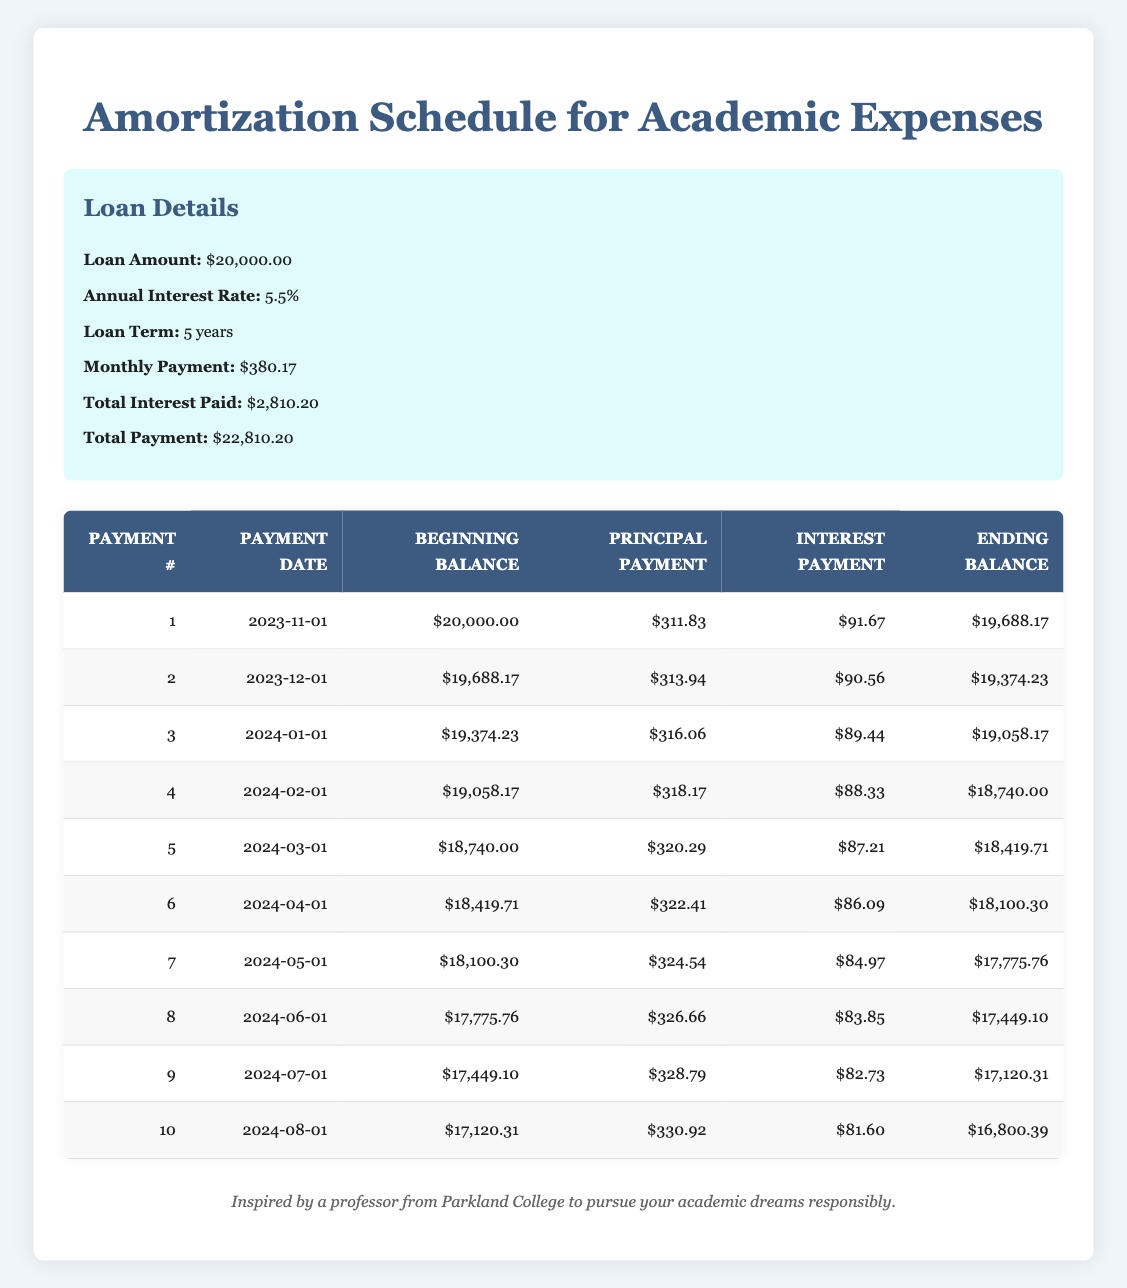What is the initial loan amount? The initial loan amount is stated directly in the loan details section of the table. It's specified as $20,000.00.
Answer: $20,000.00 What was the total interest paid over the life of the loan? Referring to the loan details, the total interest paid is presented clearly as $2,810.20.
Answer: $2,810.20 What is the principal payment of the first payment? The principal payment for the first payment is given explicitly in the first row of the amortization schedule under the "Principal Payment" column, which is $311.83.
Answer: $311.83 Is the interest payment in the second month higher than in the first month? To answer this, compare the "Interest Payment" values in rows one and two of the amortization schedule. The interest payment in the second month is $90.56, while the first month is $91.67. Since $90.56 is less than $91.67, the answer is no.
Answer: No What is the average principal payment over the first 5 payments? First, we sum the principal payments from the first five rows: (311.83 + 313.94 + 316.06 + 318.17 + 320.29) = 1,580.29. There are 5 payments, so we divide this sum by 5 to find the average: 1,580.29 / 5 = 316.06.
Answer: 316.06 How much is the ending balance after the fifth payment? According to the amortization schedule, the ending balance after the fifth payment is stated directly in the row for payment number 5 under the "Ending Balance" column, which is $18,419.71.
Answer: $18,419.71 What is the difference in principal payments between the first payment and the last payment shown? First, identify the principal payment for the last payment shown (10th payment), which is $330.92. The first payment's principal is $311.83. The difference is calculated as $330.92 - $311.83 = $19.09.
Answer: $19.09 Are there any payments where the principal payment exceeds $325.00? Reviewing the "Principal Payment" column, we see that the principal payments for payment numbers 7, 8, 9, and 10 are $324.54, $326.66, $328.79, and $330.92 respectively. Since $326.66, $328.79, and $330.92 exceed $325.00, the answer is yes.
Answer: Yes Out of the first ten payments, how many have an interest component that is less than $85.00? Looking through the "Interest Payment" column for the first ten payments, only the seventh through ten payments need to be checked. The values are $84.97, $83.85, $82.73, and $81.60. Therefore, four payments (7, 8, 9, 10) have interest components less than $85.00.
Answer: 4 